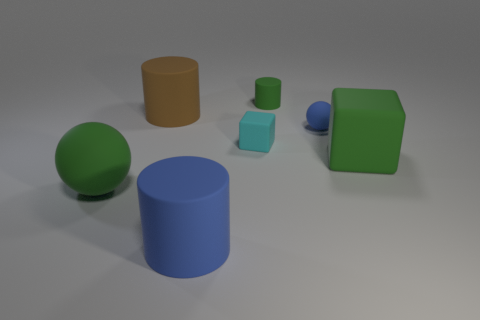Are there an equal number of big green spheres behind the tiny matte sphere and rubber cubes on the right side of the green cylinder?
Your answer should be very brief. No. Do the cyan block and the matte ball behind the large green matte cube have the same size?
Provide a short and direct response. Yes. Is the number of things that are behind the big ball greater than the number of cyan matte blocks?
Provide a short and direct response. Yes. What number of blue rubber balls are the same size as the green rubber block?
Ensure brevity in your answer.  0. Is the size of the block to the left of the green cylinder the same as the blue object in front of the green block?
Offer a terse response. No. Is the number of green matte things that are behind the big block greater than the number of tiny green objects that are in front of the blue cylinder?
Ensure brevity in your answer.  Yes. What number of tiny blue things are the same shape as the large brown object?
Make the answer very short. 0. Are there any blue balls made of the same material as the cyan cube?
Make the answer very short. Yes. Is the number of big green cubes that are in front of the blue rubber cylinder less than the number of large metal cylinders?
Provide a succinct answer. No. The green thing that is both to the left of the green block and in front of the small cylinder has what shape?
Offer a very short reply. Sphere. 